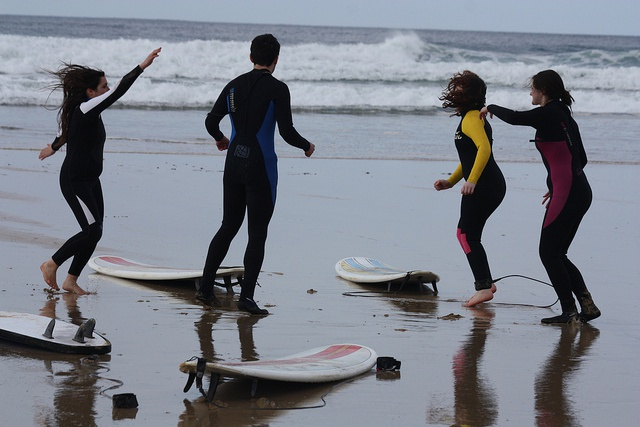Describe the objects in this image and their specific colors. I can see people in darkgray, black, navy, and gray tones, people in darkgray, black, purple, and gray tones, people in darkgray, black, gray, and maroon tones, people in darkgray, black, and olive tones, and surfboard in darkgray, gray, and black tones in this image. 